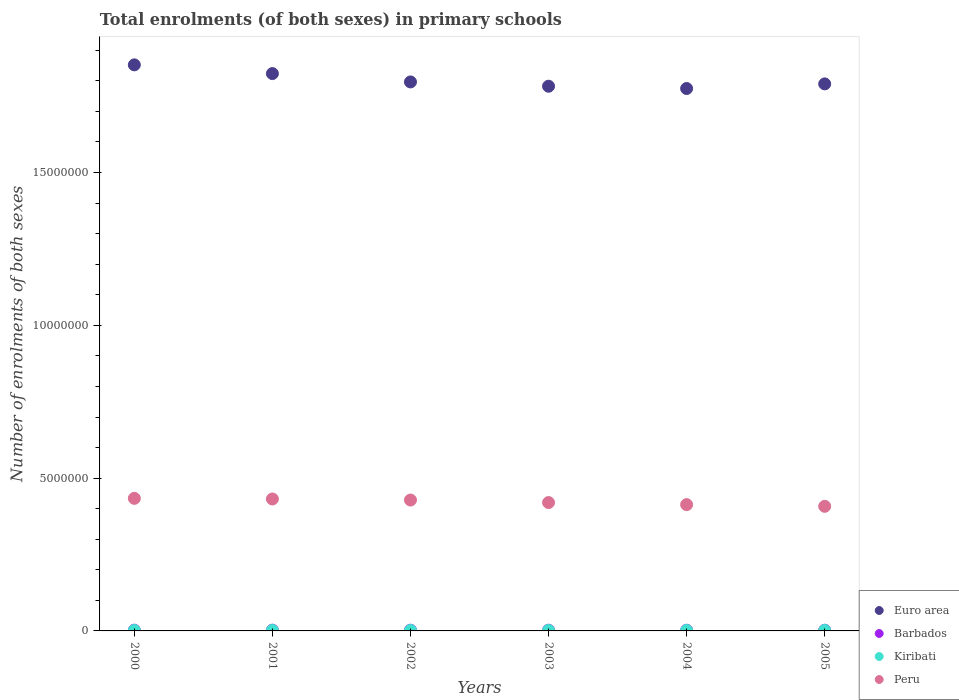How many different coloured dotlines are there?
Keep it short and to the point. 4. What is the number of enrolments in primary schools in Euro area in 2001?
Your answer should be compact. 1.82e+07. Across all years, what is the maximum number of enrolments in primary schools in Peru?
Keep it short and to the point. 4.34e+06. Across all years, what is the minimum number of enrolments in primary schools in Euro area?
Make the answer very short. 1.77e+07. What is the total number of enrolments in primary schools in Euro area in the graph?
Keep it short and to the point. 1.08e+08. What is the difference between the number of enrolments in primary schools in Barbados in 2001 and that in 2004?
Provide a short and direct response. 1898. What is the difference between the number of enrolments in primary schools in Barbados in 2001 and the number of enrolments in primary schools in Peru in 2000?
Provide a short and direct response. -4.31e+06. What is the average number of enrolments in primary schools in Peru per year?
Give a very brief answer. 4.22e+06. In the year 2001, what is the difference between the number of enrolments in primary schools in Barbados and number of enrolments in primary schools in Kiribati?
Your response must be concise. 8532. In how many years, is the number of enrolments in primary schools in Peru greater than 8000000?
Give a very brief answer. 0. What is the ratio of the number of enrolments in primary schools in Peru in 2003 to that in 2005?
Offer a very short reply. 1.03. What is the difference between the highest and the second highest number of enrolments in primary schools in Kiribati?
Your answer should be very brief. 335. What is the difference between the highest and the lowest number of enrolments in primary schools in Peru?
Provide a short and direct response. 2.61e+05. Is the sum of the number of enrolments in primary schools in Kiribati in 2003 and 2005 greater than the maximum number of enrolments in primary schools in Peru across all years?
Offer a very short reply. No. Is it the case that in every year, the sum of the number of enrolments in primary schools in Barbados and number of enrolments in primary schools in Kiribati  is greater than the sum of number of enrolments in primary schools in Peru and number of enrolments in primary schools in Euro area?
Keep it short and to the point. Yes. Is it the case that in every year, the sum of the number of enrolments in primary schools in Barbados and number of enrolments in primary schools in Kiribati  is greater than the number of enrolments in primary schools in Peru?
Your response must be concise. No. Is the number of enrolments in primary schools in Barbados strictly greater than the number of enrolments in primary schools in Kiribati over the years?
Keep it short and to the point. Yes. How many years are there in the graph?
Your answer should be compact. 6. What is the difference between two consecutive major ticks on the Y-axis?
Offer a terse response. 5.00e+06. Are the values on the major ticks of Y-axis written in scientific E-notation?
Your answer should be compact. No. What is the title of the graph?
Give a very brief answer. Total enrolments (of both sexes) in primary schools. What is the label or title of the Y-axis?
Provide a short and direct response. Number of enrolments of both sexes. What is the Number of enrolments of both sexes in Euro area in 2000?
Keep it short and to the point. 1.85e+07. What is the Number of enrolments of both sexes of Barbados in 2000?
Your response must be concise. 2.45e+04. What is the Number of enrolments of both sexes in Kiribati in 2000?
Make the answer very short. 1.46e+04. What is the Number of enrolments of both sexes of Peru in 2000?
Provide a short and direct response. 4.34e+06. What is the Number of enrolments of both sexes in Euro area in 2001?
Ensure brevity in your answer.  1.82e+07. What is the Number of enrolments of both sexes in Barbados in 2001?
Provide a succinct answer. 2.42e+04. What is the Number of enrolments of both sexes in Kiribati in 2001?
Offer a very short reply. 1.57e+04. What is the Number of enrolments of both sexes in Peru in 2001?
Provide a short and direct response. 4.32e+06. What is the Number of enrolments of both sexes of Euro area in 2002?
Your answer should be compact. 1.80e+07. What is the Number of enrolments of both sexes of Barbados in 2002?
Give a very brief answer. 2.34e+04. What is the Number of enrolments of both sexes in Kiribati in 2002?
Offer a very short reply. 1.48e+04. What is the Number of enrolments of both sexes of Peru in 2002?
Offer a very short reply. 4.28e+06. What is the Number of enrolments of both sexes of Euro area in 2003?
Your answer should be very brief. 1.78e+07. What is the Number of enrolments of both sexes in Barbados in 2003?
Your response must be concise. 2.31e+04. What is the Number of enrolments of both sexes in Kiribati in 2003?
Your response must be concise. 1.58e+04. What is the Number of enrolments of both sexes in Peru in 2003?
Your answer should be very brief. 4.20e+06. What is the Number of enrolments of both sexes in Euro area in 2004?
Offer a very short reply. 1.77e+07. What is the Number of enrolments of both sexes of Barbados in 2004?
Ensure brevity in your answer.  2.23e+04. What is the Number of enrolments of both sexes of Kiribati in 2004?
Offer a very short reply. 1.56e+04. What is the Number of enrolments of both sexes in Peru in 2004?
Offer a very short reply. 4.13e+06. What is the Number of enrolments of both sexes in Euro area in 2005?
Your answer should be very brief. 1.79e+07. What is the Number of enrolments of both sexes of Barbados in 2005?
Your answer should be very brief. 2.22e+04. What is the Number of enrolments of both sexes of Kiribati in 2005?
Ensure brevity in your answer.  1.61e+04. What is the Number of enrolments of both sexes in Peru in 2005?
Offer a terse response. 4.08e+06. Across all years, what is the maximum Number of enrolments of both sexes in Euro area?
Your answer should be very brief. 1.85e+07. Across all years, what is the maximum Number of enrolments of both sexes in Barbados?
Make the answer very short. 2.45e+04. Across all years, what is the maximum Number of enrolments of both sexes in Kiribati?
Give a very brief answer. 1.61e+04. Across all years, what is the maximum Number of enrolments of both sexes in Peru?
Ensure brevity in your answer.  4.34e+06. Across all years, what is the minimum Number of enrolments of both sexes of Euro area?
Make the answer very short. 1.77e+07. Across all years, what is the minimum Number of enrolments of both sexes in Barbados?
Your response must be concise. 2.22e+04. Across all years, what is the minimum Number of enrolments of both sexes in Kiribati?
Provide a short and direct response. 1.46e+04. Across all years, what is the minimum Number of enrolments of both sexes in Peru?
Your response must be concise. 4.08e+06. What is the total Number of enrolments of both sexes in Euro area in the graph?
Your response must be concise. 1.08e+08. What is the total Number of enrolments of both sexes of Barbados in the graph?
Keep it short and to the point. 1.40e+05. What is the total Number of enrolments of both sexes of Kiribati in the graph?
Your answer should be very brief. 9.26e+04. What is the total Number of enrolments of both sexes of Peru in the graph?
Your answer should be compact. 2.53e+07. What is the difference between the Number of enrolments of both sexes in Euro area in 2000 and that in 2001?
Give a very brief answer. 2.86e+05. What is the difference between the Number of enrolments of both sexes of Barbados in 2000 and that in 2001?
Your response must be concise. 250. What is the difference between the Number of enrolments of both sexes of Kiribati in 2000 and that in 2001?
Your response must be concise. -1127. What is the difference between the Number of enrolments of both sexes in Peru in 2000 and that in 2001?
Offer a very short reply. 2.07e+04. What is the difference between the Number of enrolments of both sexes in Euro area in 2000 and that in 2002?
Ensure brevity in your answer.  5.59e+05. What is the difference between the Number of enrolments of both sexes of Barbados in 2000 and that in 2002?
Offer a terse response. 1081. What is the difference between the Number of enrolments of both sexes in Kiribati in 2000 and that in 2002?
Keep it short and to the point. -243. What is the difference between the Number of enrolments of both sexes in Peru in 2000 and that in 2002?
Provide a succinct answer. 5.50e+04. What is the difference between the Number of enrolments of both sexes of Euro area in 2000 and that in 2003?
Give a very brief answer. 6.99e+05. What is the difference between the Number of enrolments of both sexes of Barbados in 2000 and that in 2003?
Provide a succinct answer. 1401. What is the difference between the Number of enrolments of both sexes in Kiribati in 2000 and that in 2003?
Give a very brief answer. -1232. What is the difference between the Number of enrolments of both sexes in Peru in 2000 and that in 2003?
Provide a short and direct response. 1.38e+05. What is the difference between the Number of enrolments of both sexes in Euro area in 2000 and that in 2004?
Keep it short and to the point. 7.74e+05. What is the difference between the Number of enrolments of both sexes of Barbados in 2000 and that in 2004?
Provide a short and direct response. 2148. What is the difference between the Number of enrolments of both sexes of Kiribati in 2000 and that in 2004?
Offer a terse response. -1045. What is the difference between the Number of enrolments of both sexes of Peru in 2000 and that in 2004?
Your response must be concise. 2.05e+05. What is the difference between the Number of enrolments of both sexes of Euro area in 2000 and that in 2005?
Your answer should be compact. 6.23e+05. What is the difference between the Number of enrolments of both sexes of Barbados in 2000 and that in 2005?
Your answer should be very brief. 2226. What is the difference between the Number of enrolments of both sexes of Kiribati in 2000 and that in 2005?
Your answer should be compact. -1567. What is the difference between the Number of enrolments of both sexes in Peru in 2000 and that in 2005?
Ensure brevity in your answer.  2.61e+05. What is the difference between the Number of enrolments of both sexes of Euro area in 2001 and that in 2002?
Ensure brevity in your answer.  2.73e+05. What is the difference between the Number of enrolments of both sexes in Barbados in 2001 and that in 2002?
Give a very brief answer. 831. What is the difference between the Number of enrolments of both sexes in Kiribati in 2001 and that in 2002?
Provide a short and direct response. 884. What is the difference between the Number of enrolments of both sexes of Peru in 2001 and that in 2002?
Ensure brevity in your answer.  3.43e+04. What is the difference between the Number of enrolments of both sexes of Euro area in 2001 and that in 2003?
Make the answer very short. 4.14e+05. What is the difference between the Number of enrolments of both sexes of Barbados in 2001 and that in 2003?
Offer a very short reply. 1151. What is the difference between the Number of enrolments of both sexes in Kiribati in 2001 and that in 2003?
Offer a terse response. -105. What is the difference between the Number of enrolments of both sexes in Peru in 2001 and that in 2003?
Your answer should be compact. 1.17e+05. What is the difference between the Number of enrolments of both sexes in Euro area in 2001 and that in 2004?
Keep it short and to the point. 4.89e+05. What is the difference between the Number of enrolments of both sexes of Barbados in 2001 and that in 2004?
Give a very brief answer. 1898. What is the difference between the Number of enrolments of both sexes in Kiribati in 2001 and that in 2004?
Give a very brief answer. 82. What is the difference between the Number of enrolments of both sexes of Peru in 2001 and that in 2004?
Offer a very short reply. 1.84e+05. What is the difference between the Number of enrolments of both sexes in Euro area in 2001 and that in 2005?
Offer a terse response. 3.37e+05. What is the difference between the Number of enrolments of both sexes of Barbados in 2001 and that in 2005?
Your answer should be compact. 1976. What is the difference between the Number of enrolments of both sexes of Kiribati in 2001 and that in 2005?
Offer a terse response. -440. What is the difference between the Number of enrolments of both sexes of Peru in 2001 and that in 2005?
Offer a very short reply. 2.40e+05. What is the difference between the Number of enrolments of both sexes of Euro area in 2002 and that in 2003?
Provide a succinct answer. 1.41e+05. What is the difference between the Number of enrolments of both sexes in Barbados in 2002 and that in 2003?
Your answer should be very brief. 320. What is the difference between the Number of enrolments of both sexes in Kiribati in 2002 and that in 2003?
Give a very brief answer. -989. What is the difference between the Number of enrolments of both sexes in Peru in 2002 and that in 2003?
Your answer should be compact. 8.26e+04. What is the difference between the Number of enrolments of both sexes of Euro area in 2002 and that in 2004?
Your answer should be very brief. 2.15e+05. What is the difference between the Number of enrolments of both sexes in Barbados in 2002 and that in 2004?
Your answer should be compact. 1067. What is the difference between the Number of enrolments of both sexes of Kiribati in 2002 and that in 2004?
Provide a succinct answer. -802. What is the difference between the Number of enrolments of both sexes of Peru in 2002 and that in 2004?
Offer a terse response. 1.50e+05. What is the difference between the Number of enrolments of both sexes of Euro area in 2002 and that in 2005?
Your answer should be very brief. 6.41e+04. What is the difference between the Number of enrolments of both sexes of Barbados in 2002 and that in 2005?
Your response must be concise. 1145. What is the difference between the Number of enrolments of both sexes of Kiribati in 2002 and that in 2005?
Make the answer very short. -1324. What is the difference between the Number of enrolments of both sexes of Peru in 2002 and that in 2005?
Your answer should be compact. 2.06e+05. What is the difference between the Number of enrolments of both sexes in Euro area in 2003 and that in 2004?
Your answer should be very brief. 7.46e+04. What is the difference between the Number of enrolments of both sexes of Barbados in 2003 and that in 2004?
Your answer should be compact. 747. What is the difference between the Number of enrolments of both sexes of Kiribati in 2003 and that in 2004?
Provide a succinct answer. 187. What is the difference between the Number of enrolments of both sexes of Peru in 2003 and that in 2004?
Your answer should be very brief. 6.71e+04. What is the difference between the Number of enrolments of both sexes of Euro area in 2003 and that in 2005?
Make the answer very short. -7.66e+04. What is the difference between the Number of enrolments of both sexes of Barbados in 2003 and that in 2005?
Make the answer very short. 825. What is the difference between the Number of enrolments of both sexes of Kiribati in 2003 and that in 2005?
Your answer should be very brief. -335. What is the difference between the Number of enrolments of both sexes of Peru in 2003 and that in 2005?
Offer a very short reply. 1.23e+05. What is the difference between the Number of enrolments of both sexes in Euro area in 2004 and that in 2005?
Make the answer very short. -1.51e+05. What is the difference between the Number of enrolments of both sexes in Kiribati in 2004 and that in 2005?
Provide a short and direct response. -522. What is the difference between the Number of enrolments of both sexes of Peru in 2004 and that in 2005?
Give a very brief answer. 5.60e+04. What is the difference between the Number of enrolments of both sexes in Euro area in 2000 and the Number of enrolments of both sexes in Barbados in 2001?
Offer a very short reply. 1.85e+07. What is the difference between the Number of enrolments of both sexes in Euro area in 2000 and the Number of enrolments of both sexes in Kiribati in 2001?
Ensure brevity in your answer.  1.85e+07. What is the difference between the Number of enrolments of both sexes in Euro area in 2000 and the Number of enrolments of both sexes in Peru in 2001?
Your response must be concise. 1.42e+07. What is the difference between the Number of enrolments of both sexes in Barbados in 2000 and the Number of enrolments of both sexes in Kiribati in 2001?
Keep it short and to the point. 8782. What is the difference between the Number of enrolments of both sexes in Barbados in 2000 and the Number of enrolments of both sexes in Peru in 2001?
Make the answer very short. -4.29e+06. What is the difference between the Number of enrolments of both sexes of Kiribati in 2000 and the Number of enrolments of both sexes of Peru in 2001?
Your answer should be very brief. -4.30e+06. What is the difference between the Number of enrolments of both sexes in Euro area in 2000 and the Number of enrolments of both sexes in Barbados in 2002?
Offer a terse response. 1.85e+07. What is the difference between the Number of enrolments of both sexes in Euro area in 2000 and the Number of enrolments of both sexes in Kiribati in 2002?
Your response must be concise. 1.85e+07. What is the difference between the Number of enrolments of both sexes in Euro area in 2000 and the Number of enrolments of both sexes in Peru in 2002?
Your answer should be very brief. 1.42e+07. What is the difference between the Number of enrolments of both sexes in Barbados in 2000 and the Number of enrolments of both sexes in Kiribati in 2002?
Give a very brief answer. 9666. What is the difference between the Number of enrolments of both sexes of Barbados in 2000 and the Number of enrolments of both sexes of Peru in 2002?
Offer a terse response. -4.26e+06. What is the difference between the Number of enrolments of both sexes of Kiribati in 2000 and the Number of enrolments of both sexes of Peru in 2002?
Provide a succinct answer. -4.27e+06. What is the difference between the Number of enrolments of both sexes in Euro area in 2000 and the Number of enrolments of both sexes in Barbados in 2003?
Offer a very short reply. 1.85e+07. What is the difference between the Number of enrolments of both sexes in Euro area in 2000 and the Number of enrolments of both sexes in Kiribati in 2003?
Keep it short and to the point. 1.85e+07. What is the difference between the Number of enrolments of both sexes of Euro area in 2000 and the Number of enrolments of both sexes of Peru in 2003?
Your response must be concise. 1.43e+07. What is the difference between the Number of enrolments of both sexes of Barbados in 2000 and the Number of enrolments of both sexes of Kiribati in 2003?
Your response must be concise. 8677. What is the difference between the Number of enrolments of both sexes of Barbados in 2000 and the Number of enrolments of both sexes of Peru in 2003?
Offer a terse response. -4.18e+06. What is the difference between the Number of enrolments of both sexes in Kiribati in 2000 and the Number of enrolments of both sexes in Peru in 2003?
Keep it short and to the point. -4.19e+06. What is the difference between the Number of enrolments of both sexes in Euro area in 2000 and the Number of enrolments of both sexes in Barbados in 2004?
Ensure brevity in your answer.  1.85e+07. What is the difference between the Number of enrolments of both sexes in Euro area in 2000 and the Number of enrolments of both sexes in Kiribati in 2004?
Offer a very short reply. 1.85e+07. What is the difference between the Number of enrolments of both sexes in Euro area in 2000 and the Number of enrolments of both sexes in Peru in 2004?
Your response must be concise. 1.44e+07. What is the difference between the Number of enrolments of both sexes in Barbados in 2000 and the Number of enrolments of both sexes in Kiribati in 2004?
Your answer should be compact. 8864. What is the difference between the Number of enrolments of both sexes of Barbados in 2000 and the Number of enrolments of both sexes of Peru in 2004?
Ensure brevity in your answer.  -4.11e+06. What is the difference between the Number of enrolments of both sexes in Kiribati in 2000 and the Number of enrolments of both sexes in Peru in 2004?
Provide a succinct answer. -4.12e+06. What is the difference between the Number of enrolments of both sexes of Euro area in 2000 and the Number of enrolments of both sexes of Barbados in 2005?
Your answer should be very brief. 1.85e+07. What is the difference between the Number of enrolments of both sexes in Euro area in 2000 and the Number of enrolments of both sexes in Kiribati in 2005?
Make the answer very short. 1.85e+07. What is the difference between the Number of enrolments of both sexes of Euro area in 2000 and the Number of enrolments of both sexes of Peru in 2005?
Your response must be concise. 1.44e+07. What is the difference between the Number of enrolments of both sexes in Barbados in 2000 and the Number of enrolments of both sexes in Kiribati in 2005?
Provide a short and direct response. 8342. What is the difference between the Number of enrolments of both sexes in Barbados in 2000 and the Number of enrolments of both sexes in Peru in 2005?
Offer a terse response. -4.05e+06. What is the difference between the Number of enrolments of both sexes of Kiribati in 2000 and the Number of enrolments of both sexes of Peru in 2005?
Offer a very short reply. -4.06e+06. What is the difference between the Number of enrolments of both sexes of Euro area in 2001 and the Number of enrolments of both sexes of Barbados in 2002?
Ensure brevity in your answer.  1.82e+07. What is the difference between the Number of enrolments of both sexes of Euro area in 2001 and the Number of enrolments of both sexes of Kiribati in 2002?
Keep it short and to the point. 1.82e+07. What is the difference between the Number of enrolments of both sexes of Euro area in 2001 and the Number of enrolments of both sexes of Peru in 2002?
Offer a terse response. 1.40e+07. What is the difference between the Number of enrolments of both sexes of Barbados in 2001 and the Number of enrolments of both sexes of Kiribati in 2002?
Your answer should be compact. 9416. What is the difference between the Number of enrolments of both sexes in Barbados in 2001 and the Number of enrolments of both sexes in Peru in 2002?
Your response must be concise. -4.26e+06. What is the difference between the Number of enrolments of both sexes in Kiribati in 2001 and the Number of enrolments of both sexes in Peru in 2002?
Your answer should be very brief. -4.27e+06. What is the difference between the Number of enrolments of both sexes in Euro area in 2001 and the Number of enrolments of both sexes in Barbados in 2003?
Give a very brief answer. 1.82e+07. What is the difference between the Number of enrolments of both sexes of Euro area in 2001 and the Number of enrolments of both sexes of Kiribati in 2003?
Your answer should be compact. 1.82e+07. What is the difference between the Number of enrolments of both sexes in Euro area in 2001 and the Number of enrolments of both sexes in Peru in 2003?
Provide a succinct answer. 1.40e+07. What is the difference between the Number of enrolments of both sexes of Barbados in 2001 and the Number of enrolments of both sexes of Kiribati in 2003?
Provide a short and direct response. 8427. What is the difference between the Number of enrolments of both sexes of Barbados in 2001 and the Number of enrolments of both sexes of Peru in 2003?
Make the answer very short. -4.18e+06. What is the difference between the Number of enrolments of both sexes in Kiribati in 2001 and the Number of enrolments of both sexes in Peru in 2003?
Offer a very short reply. -4.18e+06. What is the difference between the Number of enrolments of both sexes of Euro area in 2001 and the Number of enrolments of both sexes of Barbados in 2004?
Provide a succinct answer. 1.82e+07. What is the difference between the Number of enrolments of both sexes in Euro area in 2001 and the Number of enrolments of both sexes in Kiribati in 2004?
Keep it short and to the point. 1.82e+07. What is the difference between the Number of enrolments of both sexes in Euro area in 2001 and the Number of enrolments of both sexes in Peru in 2004?
Your answer should be very brief. 1.41e+07. What is the difference between the Number of enrolments of both sexes in Barbados in 2001 and the Number of enrolments of both sexes in Kiribati in 2004?
Your answer should be very brief. 8614. What is the difference between the Number of enrolments of both sexes of Barbados in 2001 and the Number of enrolments of both sexes of Peru in 2004?
Your answer should be compact. -4.11e+06. What is the difference between the Number of enrolments of both sexes in Kiribati in 2001 and the Number of enrolments of both sexes in Peru in 2004?
Offer a very short reply. -4.12e+06. What is the difference between the Number of enrolments of both sexes in Euro area in 2001 and the Number of enrolments of both sexes in Barbados in 2005?
Your response must be concise. 1.82e+07. What is the difference between the Number of enrolments of both sexes of Euro area in 2001 and the Number of enrolments of both sexes of Kiribati in 2005?
Provide a succinct answer. 1.82e+07. What is the difference between the Number of enrolments of both sexes of Euro area in 2001 and the Number of enrolments of both sexes of Peru in 2005?
Ensure brevity in your answer.  1.42e+07. What is the difference between the Number of enrolments of both sexes in Barbados in 2001 and the Number of enrolments of both sexes in Kiribati in 2005?
Provide a succinct answer. 8092. What is the difference between the Number of enrolments of both sexes in Barbados in 2001 and the Number of enrolments of both sexes in Peru in 2005?
Provide a short and direct response. -4.05e+06. What is the difference between the Number of enrolments of both sexes in Kiribati in 2001 and the Number of enrolments of both sexes in Peru in 2005?
Your response must be concise. -4.06e+06. What is the difference between the Number of enrolments of both sexes of Euro area in 2002 and the Number of enrolments of both sexes of Barbados in 2003?
Provide a short and direct response. 1.79e+07. What is the difference between the Number of enrolments of both sexes of Euro area in 2002 and the Number of enrolments of both sexes of Kiribati in 2003?
Your answer should be very brief. 1.79e+07. What is the difference between the Number of enrolments of both sexes in Euro area in 2002 and the Number of enrolments of both sexes in Peru in 2003?
Your answer should be very brief. 1.38e+07. What is the difference between the Number of enrolments of both sexes of Barbados in 2002 and the Number of enrolments of both sexes of Kiribati in 2003?
Provide a succinct answer. 7596. What is the difference between the Number of enrolments of both sexes in Barbados in 2002 and the Number of enrolments of both sexes in Peru in 2003?
Make the answer very short. -4.18e+06. What is the difference between the Number of enrolments of both sexes in Kiribati in 2002 and the Number of enrolments of both sexes in Peru in 2003?
Your answer should be compact. -4.19e+06. What is the difference between the Number of enrolments of both sexes in Euro area in 2002 and the Number of enrolments of both sexes in Barbados in 2004?
Provide a succinct answer. 1.79e+07. What is the difference between the Number of enrolments of both sexes in Euro area in 2002 and the Number of enrolments of both sexes in Kiribati in 2004?
Your response must be concise. 1.79e+07. What is the difference between the Number of enrolments of both sexes of Euro area in 2002 and the Number of enrolments of both sexes of Peru in 2004?
Offer a very short reply. 1.38e+07. What is the difference between the Number of enrolments of both sexes in Barbados in 2002 and the Number of enrolments of both sexes in Kiribati in 2004?
Keep it short and to the point. 7783. What is the difference between the Number of enrolments of both sexes in Barbados in 2002 and the Number of enrolments of both sexes in Peru in 2004?
Make the answer very short. -4.11e+06. What is the difference between the Number of enrolments of both sexes of Kiribati in 2002 and the Number of enrolments of both sexes of Peru in 2004?
Give a very brief answer. -4.12e+06. What is the difference between the Number of enrolments of both sexes of Euro area in 2002 and the Number of enrolments of both sexes of Barbados in 2005?
Your answer should be very brief. 1.79e+07. What is the difference between the Number of enrolments of both sexes of Euro area in 2002 and the Number of enrolments of both sexes of Kiribati in 2005?
Provide a short and direct response. 1.79e+07. What is the difference between the Number of enrolments of both sexes of Euro area in 2002 and the Number of enrolments of both sexes of Peru in 2005?
Your answer should be very brief. 1.39e+07. What is the difference between the Number of enrolments of both sexes in Barbados in 2002 and the Number of enrolments of both sexes in Kiribati in 2005?
Make the answer very short. 7261. What is the difference between the Number of enrolments of both sexes in Barbados in 2002 and the Number of enrolments of both sexes in Peru in 2005?
Your answer should be compact. -4.05e+06. What is the difference between the Number of enrolments of both sexes in Kiribati in 2002 and the Number of enrolments of both sexes in Peru in 2005?
Provide a short and direct response. -4.06e+06. What is the difference between the Number of enrolments of both sexes in Euro area in 2003 and the Number of enrolments of both sexes in Barbados in 2004?
Make the answer very short. 1.78e+07. What is the difference between the Number of enrolments of both sexes in Euro area in 2003 and the Number of enrolments of both sexes in Kiribati in 2004?
Ensure brevity in your answer.  1.78e+07. What is the difference between the Number of enrolments of both sexes in Euro area in 2003 and the Number of enrolments of both sexes in Peru in 2004?
Offer a very short reply. 1.37e+07. What is the difference between the Number of enrolments of both sexes in Barbados in 2003 and the Number of enrolments of both sexes in Kiribati in 2004?
Give a very brief answer. 7463. What is the difference between the Number of enrolments of both sexes in Barbados in 2003 and the Number of enrolments of both sexes in Peru in 2004?
Your response must be concise. -4.11e+06. What is the difference between the Number of enrolments of both sexes in Kiribati in 2003 and the Number of enrolments of both sexes in Peru in 2004?
Your answer should be compact. -4.12e+06. What is the difference between the Number of enrolments of both sexes of Euro area in 2003 and the Number of enrolments of both sexes of Barbados in 2005?
Provide a short and direct response. 1.78e+07. What is the difference between the Number of enrolments of both sexes in Euro area in 2003 and the Number of enrolments of both sexes in Kiribati in 2005?
Ensure brevity in your answer.  1.78e+07. What is the difference between the Number of enrolments of both sexes of Euro area in 2003 and the Number of enrolments of both sexes of Peru in 2005?
Provide a succinct answer. 1.37e+07. What is the difference between the Number of enrolments of both sexes in Barbados in 2003 and the Number of enrolments of both sexes in Kiribati in 2005?
Offer a very short reply. 6941. What is the difference between the Number of enrolments of both sexes in Barbados in 2003 and the Number of enrolments of both sexes in Peru in 2005?
Give a very brief answer. -4.05e+06. What is the difference between the Number of enrolments of both sexes of Kiribati in 2003 and the Number of enrolments of both sexes of Peru in 2005?
Provide a short and direct response. -4.06e+06. What is the difference between the Number of enrolments of both sexes of Euro area in 2004 and the Number of enrolments of both sexes of Barbados in 2005?
Offer a terse response. 1.77e+07. What is the difference between the Number of enrolments of both sexes of Euro area in 2004 and the Number of enrolments of both sexes of Kiribati in 2005?
Your answer should be very brief. 1.77e+07. What is the difference between the Number of enrolments of both sexes of Euro area in 2004 and the Number of enrolments of both sexes of Peru in 2005?
Your answer should be compact. 1.37e+07. What is the difference between the Number of enrolments of both sexes in Barbados in 2004 and the Number of enrolments of both sexes in Kiribati in 2005?
Provide a succinct answer. 6194. What is the difference between the Number of enrolments of both sexes in Barbados in 2004 and the Number of enrolments of both sexes in Peru in 2005?
Keep it short and to the point. -4.06e+06. What is the difference between the Number of enrolments of both sexes in Kiribati in 2004 and the Number of enrolments of both sexes in Peru in 2005?
Offer a terse response. -4.06e+06. What is the average Number of enrolments of both sexes of Euro area per year?
Provide a short and direct response. 1.80e+07. What is the average Number of enrolments of both sexes in Barbados per year?
Your response must be concise. 2.33e+04. What is the average Number of enrolments of both sexes of Kiribati per year?
Your response must be concise. 1.54e+04. What is the average Number of enrolments of both sexes of Peru per year?
Your response must be concise. 4.22e+06. In the year 2000, what is the difference between the Number of enrolments of both sexes of Euro area and Number of enrolments of both sexes of Barbados?
Ensure brevity in your answer.  1.85e+07. In the year 2000, what is the difference between the Number of enrolments of both sexes of Euro area and Number of enrolments of both sexes of Kiribati?
Offer a very short reply. 1.85e+07. In the year 2000, what is the difference between the Number of enrolments of both sexes of Euro area and Number of enrolments of both sexes of Peru?
Provide a succinct answer. 1.42e+07. In the year 2000, what is the difference between the Number of enrolments of both sexes of Barbados and Number of enrolments of both sexes of Kiribati?
Make the answer very short. 9909. In the year 2000, what is the difference between the Number of enrolments of both sexes of Barbados and Number of enrolments of both sexes of Peru?
Your answer should be compact. -4.31e+06. In the year 2000, what is the difference between the Number of enrolments of both sexes of Kiribati and Number of enrolments of both sexes of Peru?
Provide a short and direct response. -4.32e+06. In the year 2001, what is the difference between the Number of enrolments of both sexes in Euro area and Number of enrolments of both sexes in Barbados?
Provide a short and direct response. 1.82e+07. In the year 2001, what is the difference between the Number of enrolments of both sexes in Euro area and Number of enrolments of both sexes in Kiribati?
Offer a very short reply. 1.82e+07. In the year 2001, what is the difference between the Number of enrolments of both sexes in Euro area and Number of enrolments of both sexes in Peru?
Offer a very short reply. 1.39e+07. In the year 2001, what is the difference between the Number of enrolments of both sexes of Barbados and Number of enrolments of both sexes of Kiribati?
Offer a very short reply. 8532. In the year 2001, what is the difference between the Number of enrolments of both sexes in Barbados and Number of enrolments of both sexes in Peru?
Ensure brevity in your answer.  -4.29e+06. In the year 2001, what is the difference between the Number of enrolments of both sexes in Kiribati and Number of enrolments of both sexes in Peru?
Your answer should be compact. -4.30e+06. In the year 2002, what is the difference between the Number of enrolments of both sexes of Euro area and Number of enrolments of both sexes of Barbados?
Your answer should be very brief. 1.79e+07. In the year 2002, what is the difference between the Number of enrolments of both sexes of Euro area and Number of enrolments of both sexes of Kiribati?
Provide a succinct answer. 1.80e+07. In the year 2002, what is the difference between the Number of enrolments of both sexes of Euro area and Number of enrolments of both sexes of Peru?
Offer a terse response. 1.37e+07. In the year 2002, what is the difference between the Number of enrolments of both sexes of Barbados and Number of enrolments of both sexes of Kiribati?
Your response must be concise. 8585. In the year 2002, what is the difference between the Number of enrolments of both sexes in Barbados and Number of enrolments of both sexes in Peru?
Your answer should be compact. -4.26e+06. In the year 2002, what is the difference between the Number of enrolments of both sexes in Kiribati and Number of enrolments of both sexes in Peru?
Your answer should be compact. -4.27e+06. In the year 2003, what is the difference between the Number of enrolments of both sexes of Euro area and Number of enrolments of both sexes of Barbados?
Ensure brevity in your answer.  1.78e+07. In the year 2003, what is the difference between the Number of enrolments of both sexes of Euro area and Number of enrolments of both sexes of Kiribati?
Your response must be concise. 1.78e+07. In the year 2003, what is the difference between the Number of enrolments of both sexes in Euro area and Number of enrolments of both sexes in Peru?
Provide a short and direct response. 1.36e+07. In the year 2003, what is the difference between the Number of enrolments of both sexes in Barbados and Number of enrolments of both sexes in Kiribati?
Make the answer very short. 7276. In the year 2003, what is the difference between the Number of enrolments of both sexes of Barbados and Number of enrolments of both sexes of Peru?
Give a very brief answer. -4.18e+06. In the year 2003, what is the difference between the Number of enrolments of both sexes of Kiribati and Number of enrolments of both sexes of Peru?
Offer a terse response. -4.18e+06. In the year 2004, what is the difference between the Number of enrolments of both sexes of Euro area and Number of enrolments of both sexes of Barbados?
Give a very brief answer. 1.77e+07. In the year 2004, what is the difference between the Number of enrolments of both sexes of Euro area and Number of enrolments of both sexes of Kiribati?
Give a very brief answer. 1.77e+07. In the year 2004, what is the difference between the Number of enrolments of both sexes in Euro area and Number of enrolments of both sexes in Peru?
Offer a very short reply. 1.36e+07. In the year 2004, what is the difference between the Number of enrolments of both sexes in Barbados and Number of enrolments of both sexes in Kiribati?
Your answer should be very brief. 6716. In the year 2004, what is the difference between the Number of enrolments of both sexes in Barbados and Number of enrolments of both sexes in Peru?
Provide a succinct answer. -4.11e+06. In the year 2004, what is the difference between the Number of enrolments of both sexes of Kiribati and Number of enrolments of both sexes of Peru?
Offer a very short reply. -4.12e+06. In the year 2005, what is the difference between the Number of enrolments of both sexes of Euro area and Number of enrolments of both sexes of Barbados?
Keep it short and to the point. 1.79e+07. In the year 2005, what is the difference between the Number of enrolments of both sexes of Euro area and Number of enrolments of both sexes of Kiribati?
Ensure brevity in your answer.  1.79e+07. In the year 2005, what is the difference between the Number of enrolments of both sexes in Euro area and Number of enrolments of both sexes in Peru?
Your answer should be compact. 1.38e+07. In the year 2005, what is the difference between the Number of enrolments of both sexes of Barbados and Number of enrolments of both sexes of Kiribati?
Give a very brief answer. 6116. In the year 2005, what is the difference between the Number of enrolments of both sexes in Barbados and Number of enrolments of both sexes in Peru?
Your answer should be very brief. -4.06e+06. In the year 2005, what is the difference between the Number of enrolments of both sexes in Kiribati and Number of enrolments of both sexes in Peru?
Your response must be concise. -4.06e+06. What is the ratio of the Number of enrolments of both sexes in Euro area in 2000 to that in 2001?
Offer a terse response. 1.02. What is the ratio of the Number of enrolments of both sexes in Barbados in 2000 to that in 2001?
Provide a succinct answer. 1.01. What is the ratio of the Number of enrolments of both sexes of Kiribati in 2000 to that in 2001?
Offer a very short reply. 0.93. What is the ratio of the Number of enrolments of both sexes in Euro area in 2000 to that in 2002?
Your answer should be compact. 1.03. What is the ratio of the Number of enrolments of both sexes in Barbados in 2000 to that in 2002?
Your answer should be compact. 1.05. What is the ratio of the Number of enrolments of both sexes of Kiribati in 2000 to that in 2002?
Make the answer very short. 0.98. What is the ratio of the Number of enrolments of both sexes in Peru in 2000 to that in 2002?
Provide a short and direct response. 1.01. What is the ratio of the Number of enrolments of both sexes in Euro area in 2000 to that in 2003?
Provide a succinct answer. 1.04. What is the ratio of the Number of enrolments of both sexes of Barbados in 2000 to that in 2003?
Offer a very short reply. 1.06. What is the ratio of the Number of enrolments of both sexes of Kiribati in 2000 to that in 2003?
Provide a short and direct response. 0.92. What is the ratio of the Number of enrolments of both sexes in Peru in 2000 to that in 2003?
Make the answer very short. 1.03. What is the ratio of the Number of enrolments of both sexes in Euro area in 2000 to that in 2004?
Ensure brevity in your answer.  1.04. What is the ratio of the Number of enrolments of both sexes in Barbados in 2000 to that in 2004?
Offer a very short reply. 1.1. What is the ratio of the Number of enrolments of both sexes of Kiribati in 2000 to that in 2004?
Provide a succinct answer. 0.93. What is the ratio of the Number of enrolments of both sexes of Peru in 2000 to that in 2004?
Offer a very short reply. 1.05. What is the ratio of the Number of enrolments of both sexes in Euro area in 2000 to that in 2005?
Your answer should be very brief. 1.03. What is the ratio of the Number of enrolments of both sexes of Kiribati in 2000 to that in 2005?
Keep it short and to the point. 0.9. What is the ratio of the Number of enrolments of both sexes in Peru in 2000 to that in 2005?
Offer a very short reply. 1.06. What is the ratio of the Number of enrolments of both sexes in Euro area in 2001 to that in 2002?
Ensure brevity in your answer.  1.02. What is the ratio of the Number of enrolments of both sexes of Barbados in 2001 to that in 2002?
Your answer should be compact. 1.04. What is the ratio of the Number of enrolments of both sexes of Kiribati in 2001 to that in 2002?
Your response must be concise. 1.06. What is the ratio of the Number of enrolments of both sexes of Peru in 2001 to that in 2002?
Your response must be concise. 1.01. What is the ratio of the Number of enrolments of both sexes of Euro area in 2001 to that in 2003?
Your answer should be compact. 1.02. What is the ratio of the Number of enrolments of both sexes of Barbados in 2001 to that in 2003?
Ensure brevity in your answer.  1.05. What is the ratio of the Number of enrolments of both sexes in Kiribati in 2001 to that in 2003?
Your answer should be very brief. 0.99. What is the ratio of the Number of enrolments of both sexes of Peru in 2001 to that in 2003?
Your answer should be compact. 1.03. What is the ratio of the Number of enrolments of both sexes of Euro area in 2001 to that in 2004?
Provide a succinct answer. 1.03. What is the ratio of the Number of enrolments of both sexes in Barbados in 2001 to that in 2004?
Offer a very short reply. 1.08. What is the ratio of the Number of enrolments of both sexes of Kiribati in 2001 to that in 2004?
Your answer should be compact. 1.01. What is the ratio of the Number of enrolments of both sexes in Peru in 2001 to that in 2004?
Provide a succinct answer. 1.04. What is the ratio of the Number of enrolments of both sexes of Euro area in 2001 to that in 2005?
Provide a short and direct response. 1.02. What is the ratio of the Number of enrolments of both sexes in Barbados in 2001 to that in 2005?
Your response must be concise. 1.09. What is the ratio of the Number of enrolments of both sexes of Kiribati in 2001 to that in 2005?
Give a very brief answer. 0.97. What is the ratio of the Number of enrolments of both sexes in Peru in 2001 to that in 2005?
Your response must be concise. 1.06. What is the ratio of the Number of enrolments of both sexes in Euro area in 2002 to that in 2003?
Ensure brevity in your answer.  1.01. What is the ratio of the Number of enrolments of both sexes in Barbados in 2002 to that in 2003?
Ensure brevity in your answer.  1.01. What is the ratio of the Number of enrolments of both sexes of Kiribati in 2002 to that in 2003?
Keep it short and to the point. 0.94. What is the ratio of the Number of enrolments of both sexes in Peru in 2002 to that in 2003?
Ensure brevity in your answer.  1.02. What is the ratio of the Number of enrolments of both sexes in Euro area in 2002 to that in 2004?
Your answer should be very brief. 1.01. What is the ratio of the Number of enrolments of both sexes of Barbados in 2002 to that in 2004?
Provide a short and direct response. 1.05. What is the ratio of the Number of enrolments of both sexes of Kiribati in 2002 to that in 2004?
Make the answer very short. 0.95. What is the ratio of the Number of enrolments of both sexes of Peru in 2002 to that in 2004?
Provide a succinct answer. 1.04. What is the ratio of the Number of enrolments of both sexes in Barbados in 2002 to that in 2005?
Your response must be concise. 1.05. What is the ratio of the Number of enrolments of both sexes of Kiribati in 2002 to that in 2005?
Your answer should be compact. 0.92. What is the ratio of the Number of enrolments of both sexes in Peru in 2002 to that in 2005?
Offer a terse response. 1.05. What is the ratio of the Number of enrolments of both sexes in Barbados in 2003 to that in 2004?
Your answer should be very brief. 1.03. What is the ratio of the Number of enrolments of both sexes of Peru in 2003 to that in 2004?
Your answer should be compact. 1.02. What is the ratio of the Number of enrolments of both sexes of Euro area in 2003 to that in 2005?
Offer a terse response. 1. What is the ratio of the Number of enrolments of both sexes of Barbados in 2003 to that in 2005?
Offer a terse response. 1.04. What is the ratio of the Number of enrolments of both sexes of Kiribati in 2003 to that in 2005?
Ensure brevity in your answer.  0.98. What is the ratio of the Number of enrolments of both sexes in Peru in 2003 to that in 2005?
Make the answer very short. 1.03. What is the ratio of the Number of enrolments of both sexes in Euro area in 2004 to that in 2005?
Your answer should be compact. 0.99. What is the ratio of the Number of enrolments of both sexes of Barbados in 2004 to that in 2005?
Your answer should be compact. 1. What is the ratio of the Number of enrolments of both sexes in Kiribati in 2004 to that in 2005?
Your response must be concise. 0.97. What is the ratio of the Number of enrolments of both sexes of Peru in 2004 to that in 2005?
Provide a short and direct response. 1.01. What is the difference between the highest and the second highest Number of enrolments of both sexes of Euro area?
Your response must be concise. 2.86e+05. What is the difference between the highest and the second highest Number of enrolments of both sexes of Barbados?
Your answer should be compact. 250. What is the difference between the highest and the second highest Number of enrolments of both sexes in Kiribati?
Offer a very short reply. 335. What is the difference between the highest and the second highest Number of enrolments of both sexes of Peru?
Make the answer very short. 2.07e+04. What is the difference between the highest and the lowest Number of enrolments of both sexes in Euro area?
Keep it short and to the point. 7.74e+05. What is the difference between the highest and the lowest Number of enrolments of both sexes in Barbados?
Keep it short and to the point. 2226. What is the difference between the highest and the lowest Number of enrolments of both sexes in Kiribati?
Keep it short and to the point. 1567. What is the difference between the highest and the lowest Number of enrolments of both sexes of Peru?
Give a very brief answer. 2.61e+05. 